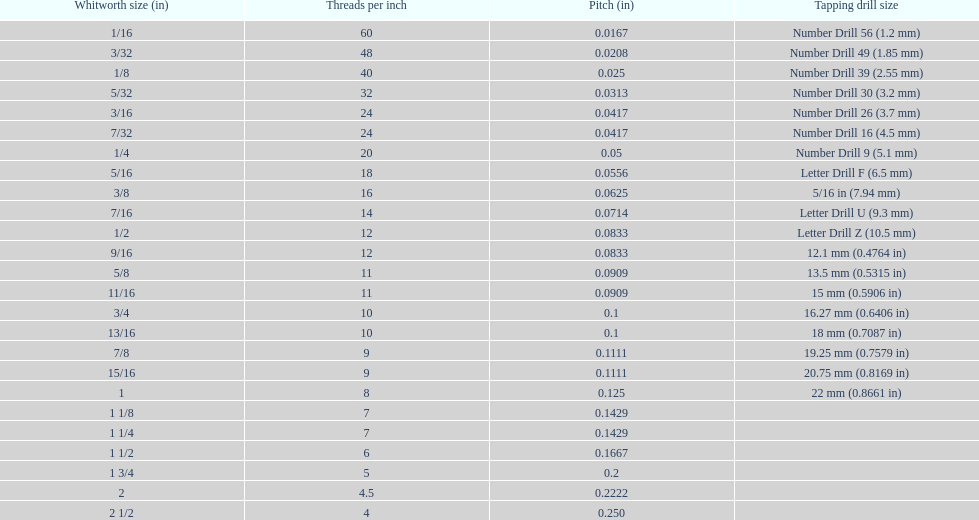What is the top amount of threads per inch? 60. 